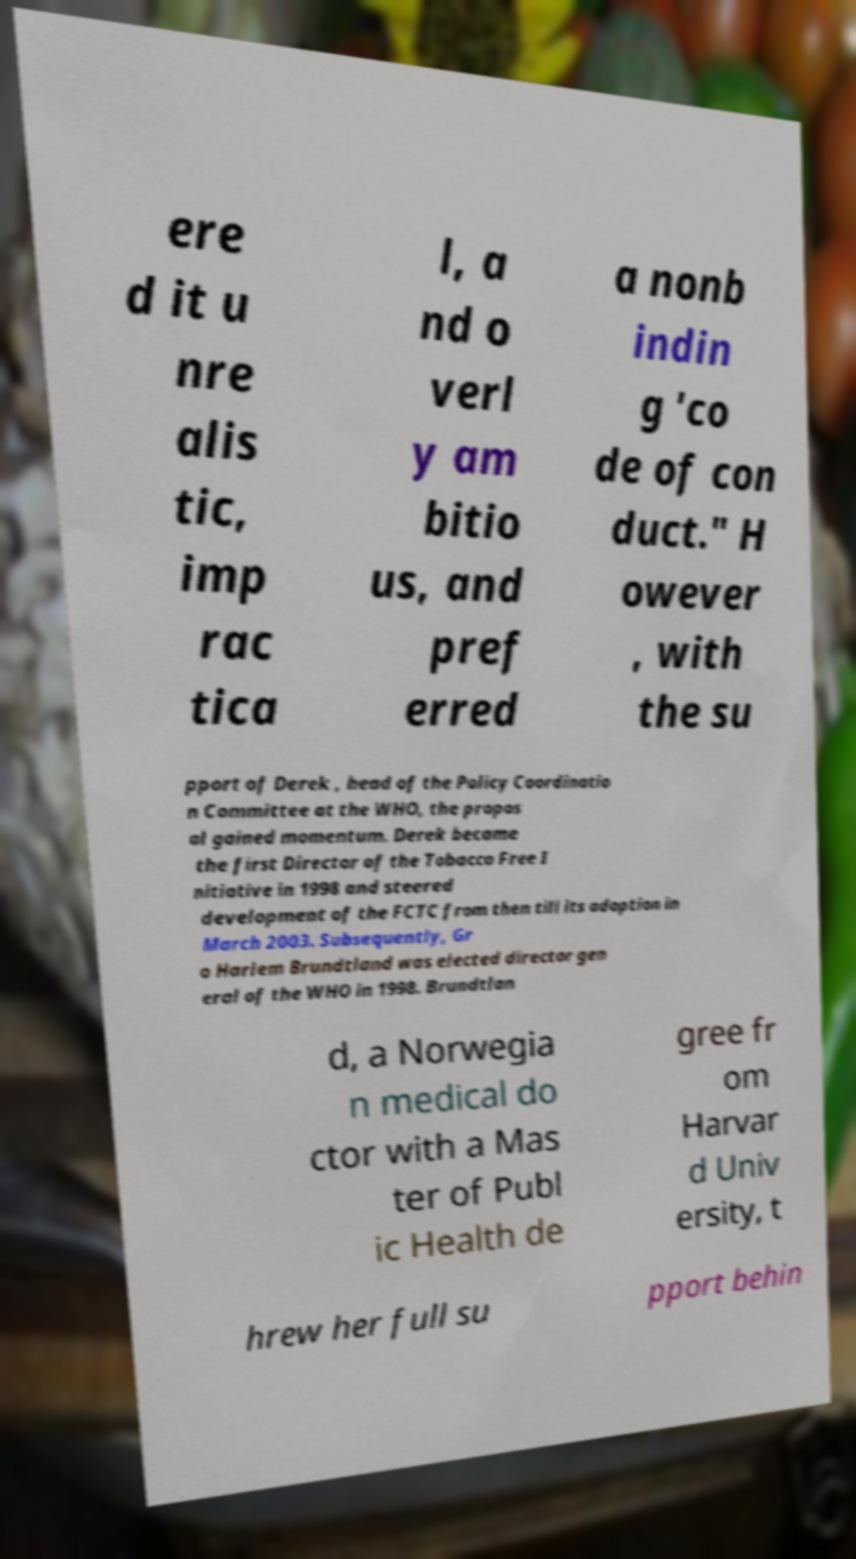Can you read and provide the text displayed in the image?This photo seems to have some interesting text. Can you extract and type it out for me? ere d it u nre alis tic, imp rac tica l, a nd o verl y am bitio us, and pref erred a nonb indin g 'co de of con duct." H owever , with the su pport of Derek , head of the Policy Coordinatio n Committee at the WHO, the propos al gained momentum. Derek became the first Director of the Tobacco Free I nitiative in 1998 and steered development of the FCTC from then till its adoption in March 2003. Subsequently, Gr o Harlem Brundtland was elected director gen eral of the WHO in 1998. Brundtlan d, a Norwegia n medical do ctor with a Mas ter of Publ ic Health de gree fr om Harvar d Univ ersity, t hrew her full su pport behin 